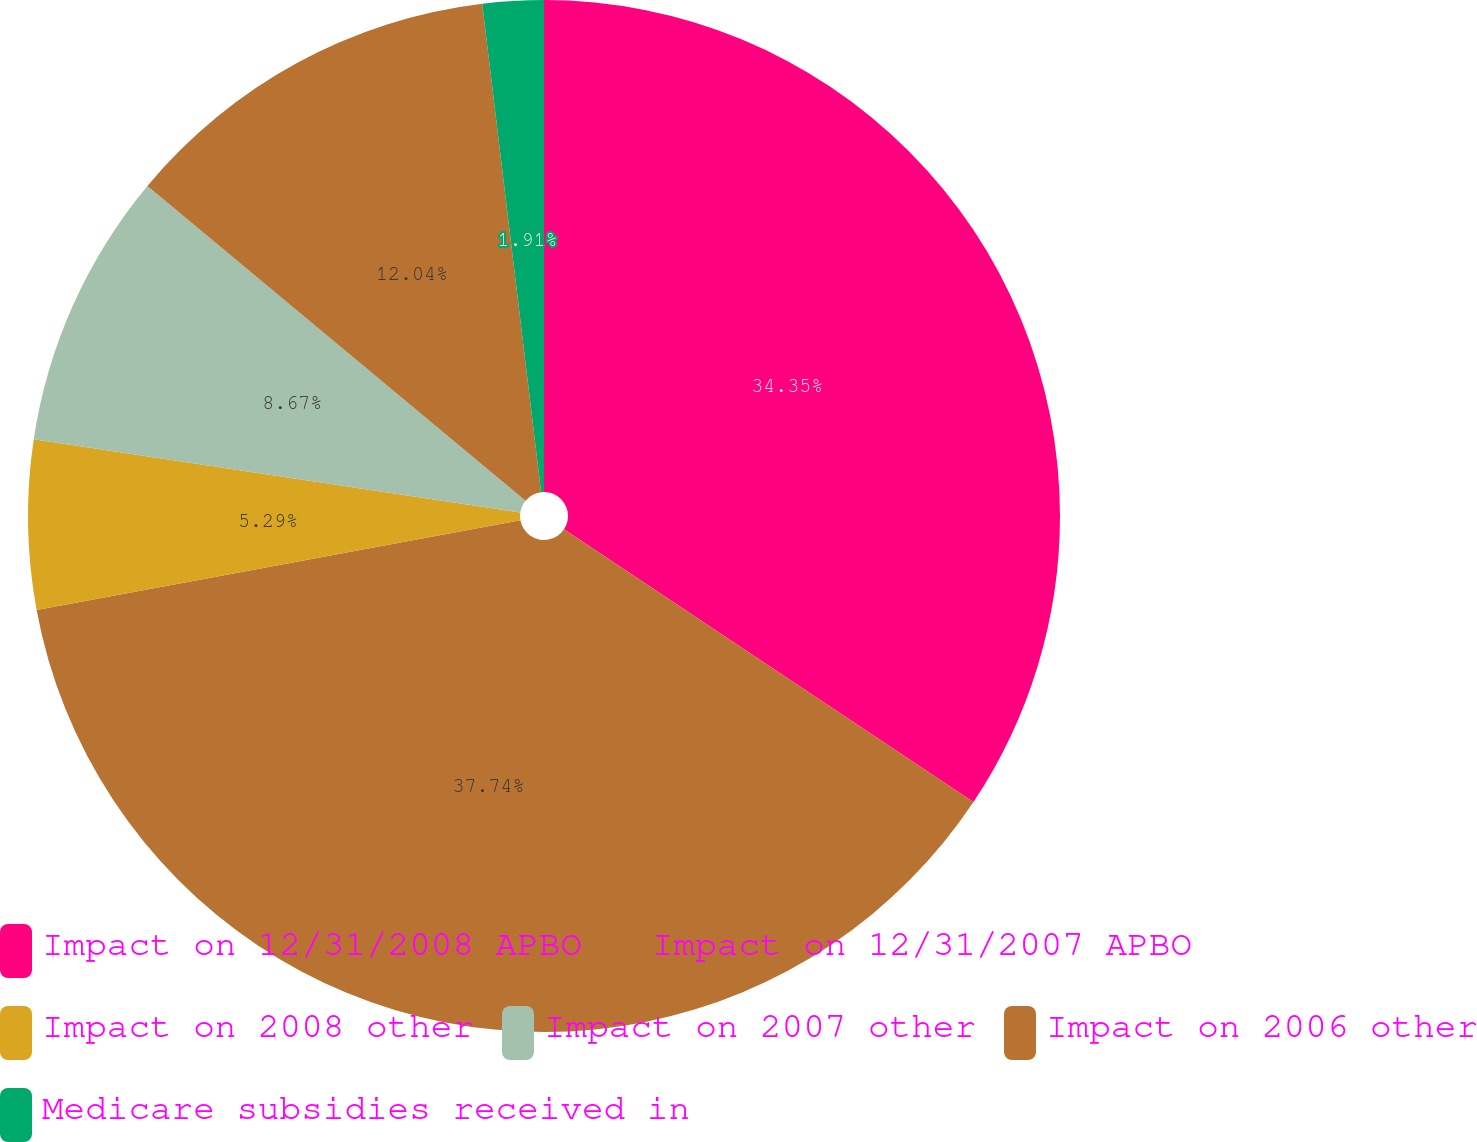<chart> <loc_0><loc_0><loc_500><loc_500><pie_chart><fcel>Impact on 12/31/2008 APBO<fcel>Impact on 12/31/2007 APBO<fcel>Impact on 2008 other<fcel>Impact on 2007 other<fcel>Impact on 2006 other<fcel>Medicare subsidies received in<nl><fcel>34.35%<fcel>37.73%<fcel>5.29%<fcel>8.67%<fcel>12.04%<fcel>1.91%<nl></chart> 